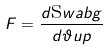Convert formula to latex. <formula><loc_0><loc_0><loc_500><loc_500>F = \frac { d \text  swab{g} } { d \vartheta u p }</formula> 